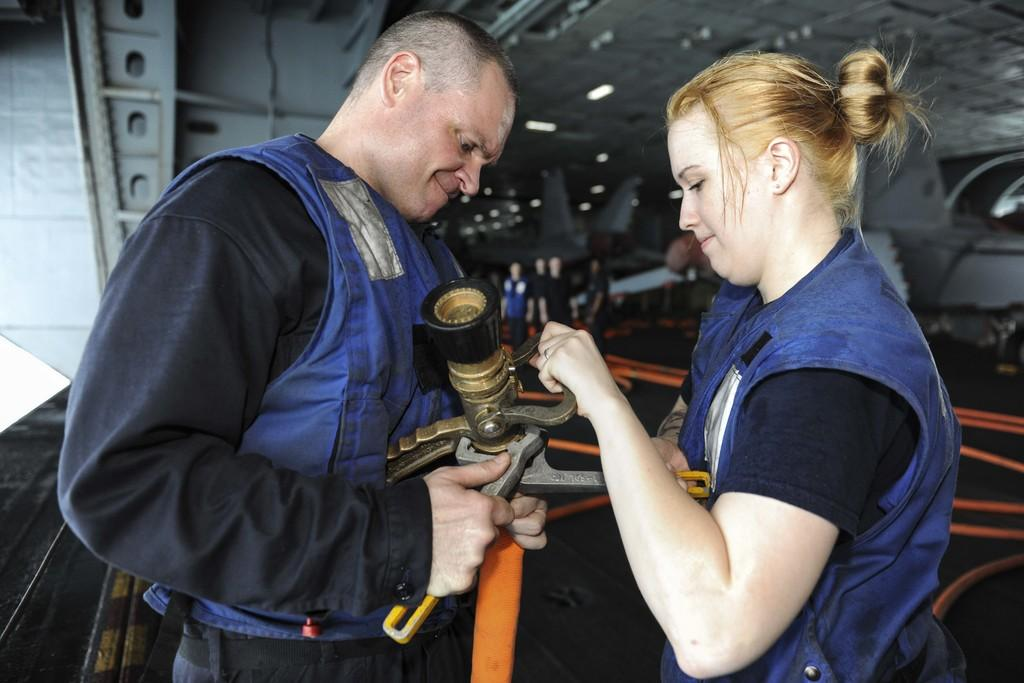How many people are present in the image? There are two persons standing in the image. What are the two persons holding? The two persons are holding an object. Can you describe the background of the image? There is a group of people standing in the background of the image. What can be seen in the image that provides illumination? Lights are visible in the image. How many goldfish are swimming in the can in the image? There are no goldfish or cans present in the image. 